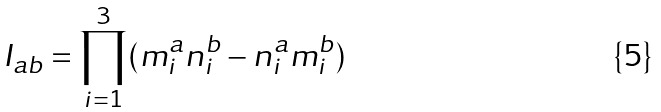<formula> <loc_0><loc_0><loc_500><loc_500>I _ { a b } = \prod _ { i = 1 } ^ { 3 } ( m ^ { a } _ { i } n ^ { b } _ { i } - n ^ { a } _ { i } m ^ { b } _ { i } )</formula> 